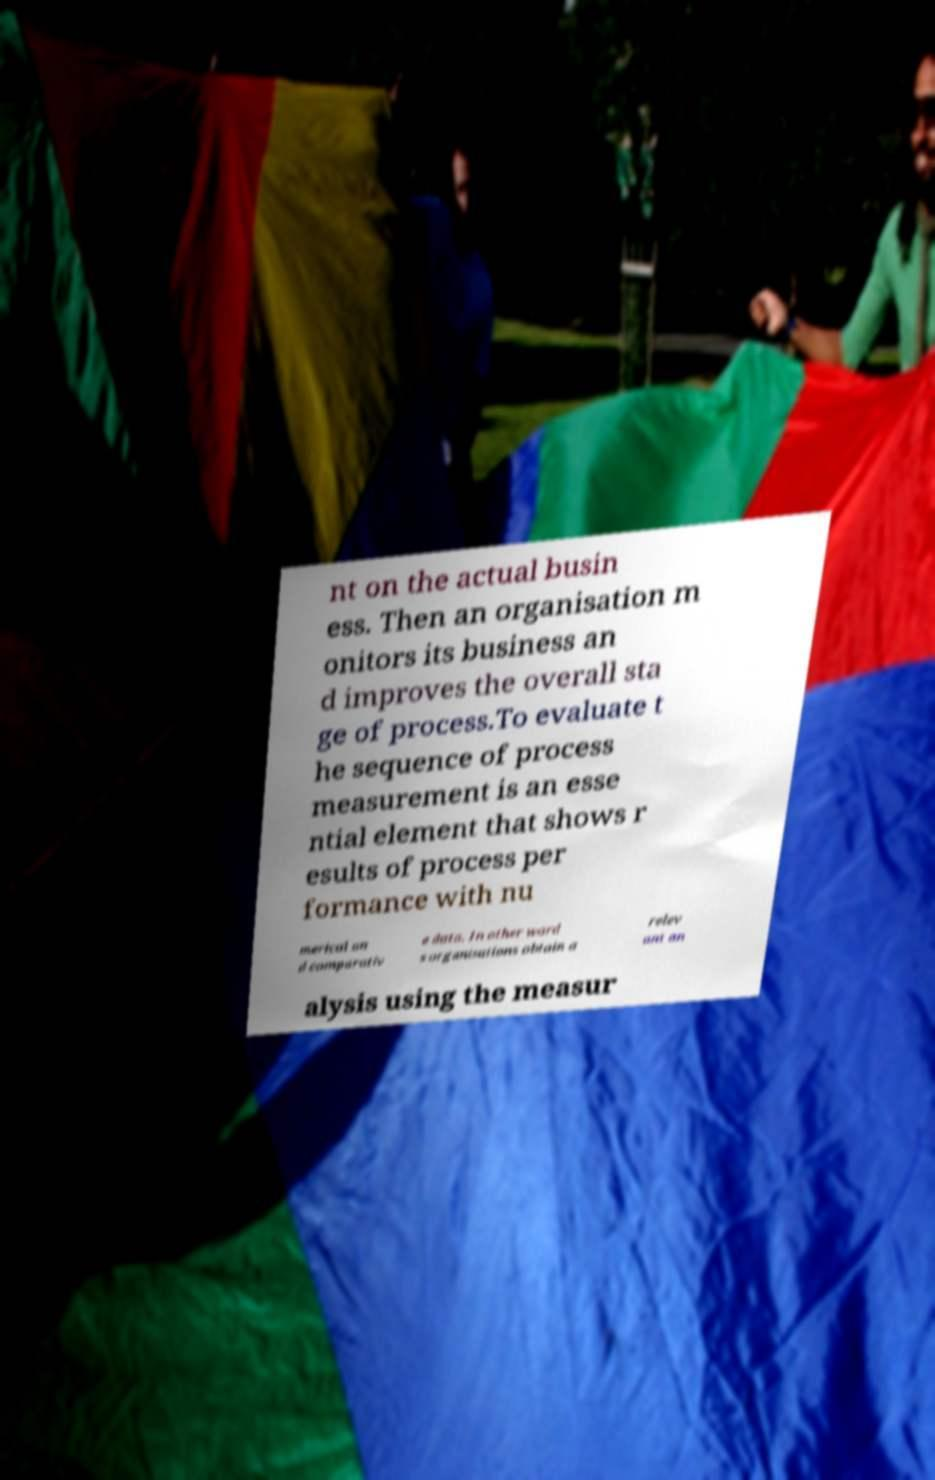There's text embedded in this image that I need extracted. Can you transcribe it verbatim? nt on the actual busin ess. Then an organisation m onitors its business an d improves the overall sta ge of process.To evaluate t he sequence of process measurement is an esse ntial element that shows r esults of process per formance with nu merical an d comparativ e data. In other word s organisations obtain a relev ant an alysis using the measur 